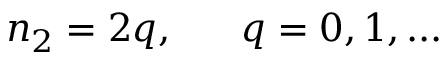Convert formula to latex. <formula><loc_0><loc_0><loc_500><loc_500>n _ { 2 } = 2 q , \quad \ q = 0 , 1 , \dots</formula> 